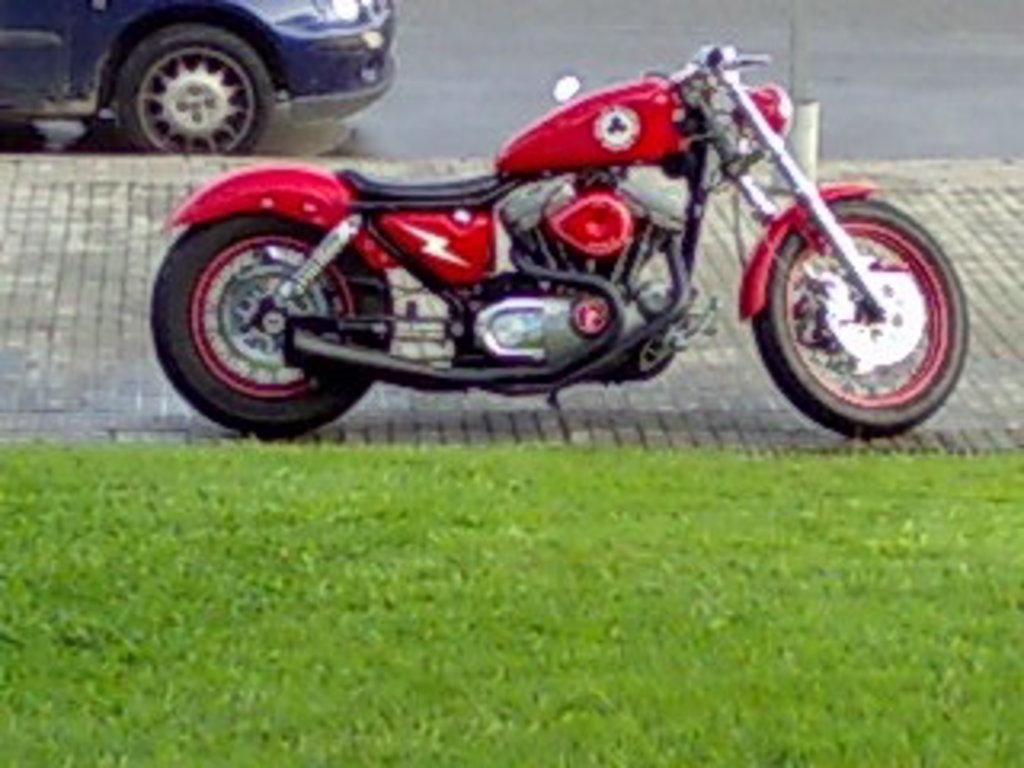What type of objects are present on the floor and road in the image? There are motor vehicles in the image. Can you describe the location of the motor vehicles in the image? The motor vehicles are on the floor and road in the image. What type of vegetation can be seen in the foreground of the image? There is grass in the foreground of the image. What type of music can be heard coming from the vessel in the image? There is no vessel present in the image, and therefore no music can be heard. 